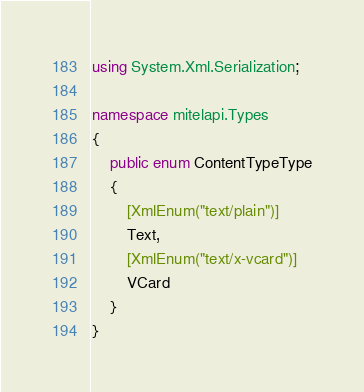<code> <loc_0><loc_0><loc_500><loc_500><_C#_>using System.Xml.Serialization;

namespace mitelapi.Types
{
    public enum ContentTypeType
    {
        [XmlEnum("text/plain")]
        Text,
        [XmlEnum("text/x-vcard")]
        VCard
    }
}</code> 